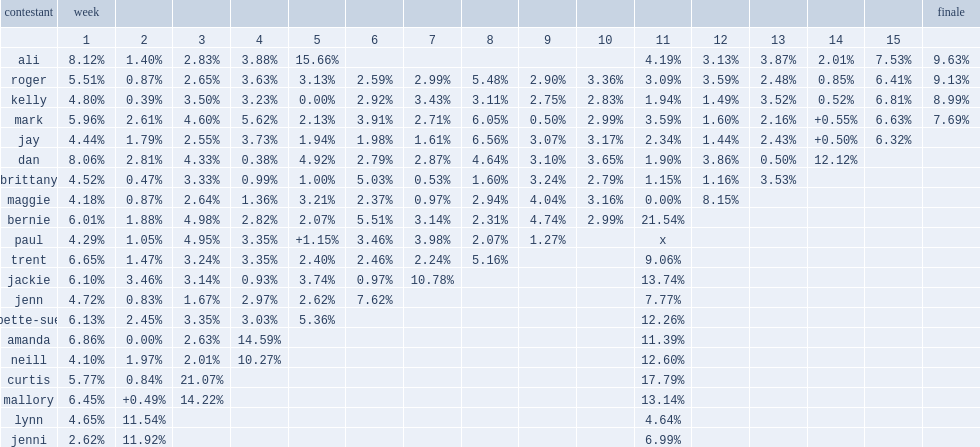What was the percentage that ali dropped in the 11th week? 4.19. 